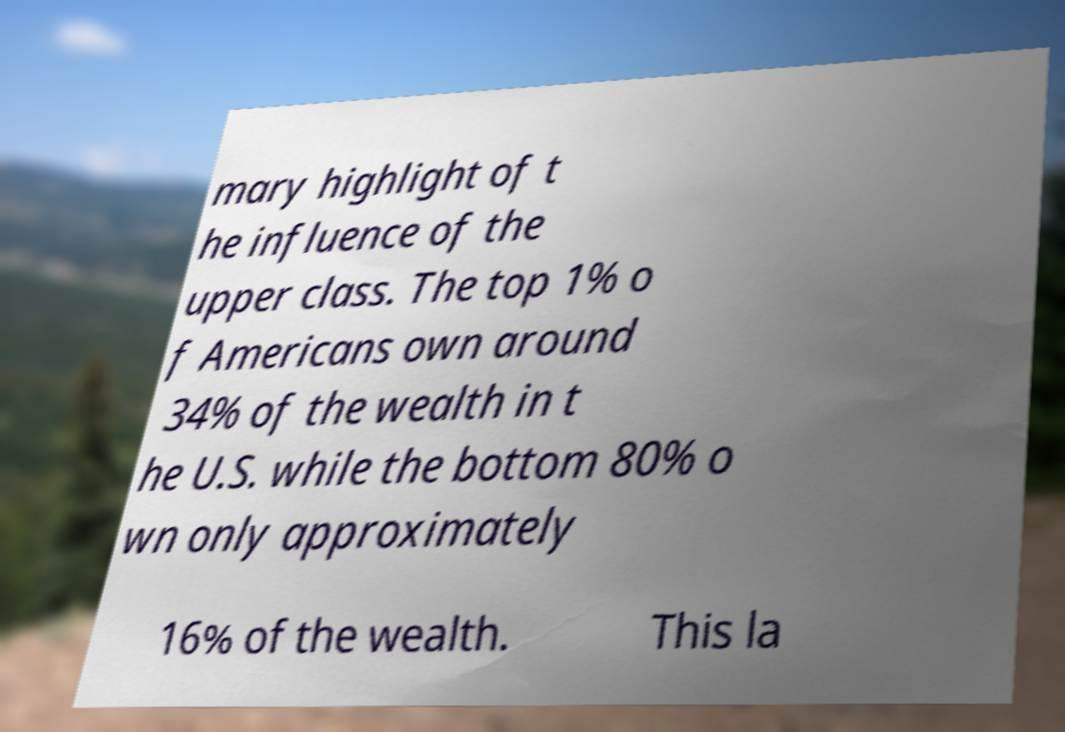Could you assist in decoding the text presented in this image and type it out clearly? mary highlight of t he influence of the upper class. The top 1% o f Americans own around 34% of the wealth in t he U.S. while the bottom 80% o wn only approximately 16% of the wealth. This la 